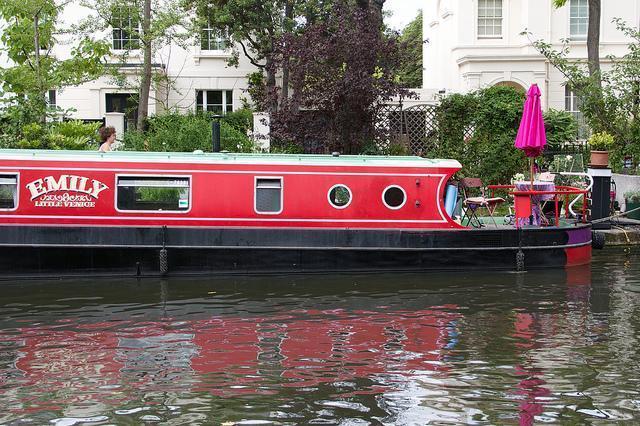Does the image validate the caption "The potted plant is near the boat."?
Answer yes or no. Yes. Does the caption "The boat is left of the potted plant." correctly depict the image?
Answer yes or no. Yes. Is this affirmation: "The umbrella is away from the boat." correct?
Answer yes or no. No. Is this affirmation: "The umbrella is on the boat." correct?
Answer yes or no. Yes. Does the description: "The boat is behind the dining table." accurately reflect the image?
Answer yes or no. No. Is "The dining table is on the boat." an appropriate description for the image?
Answer yes or no. Yes. 